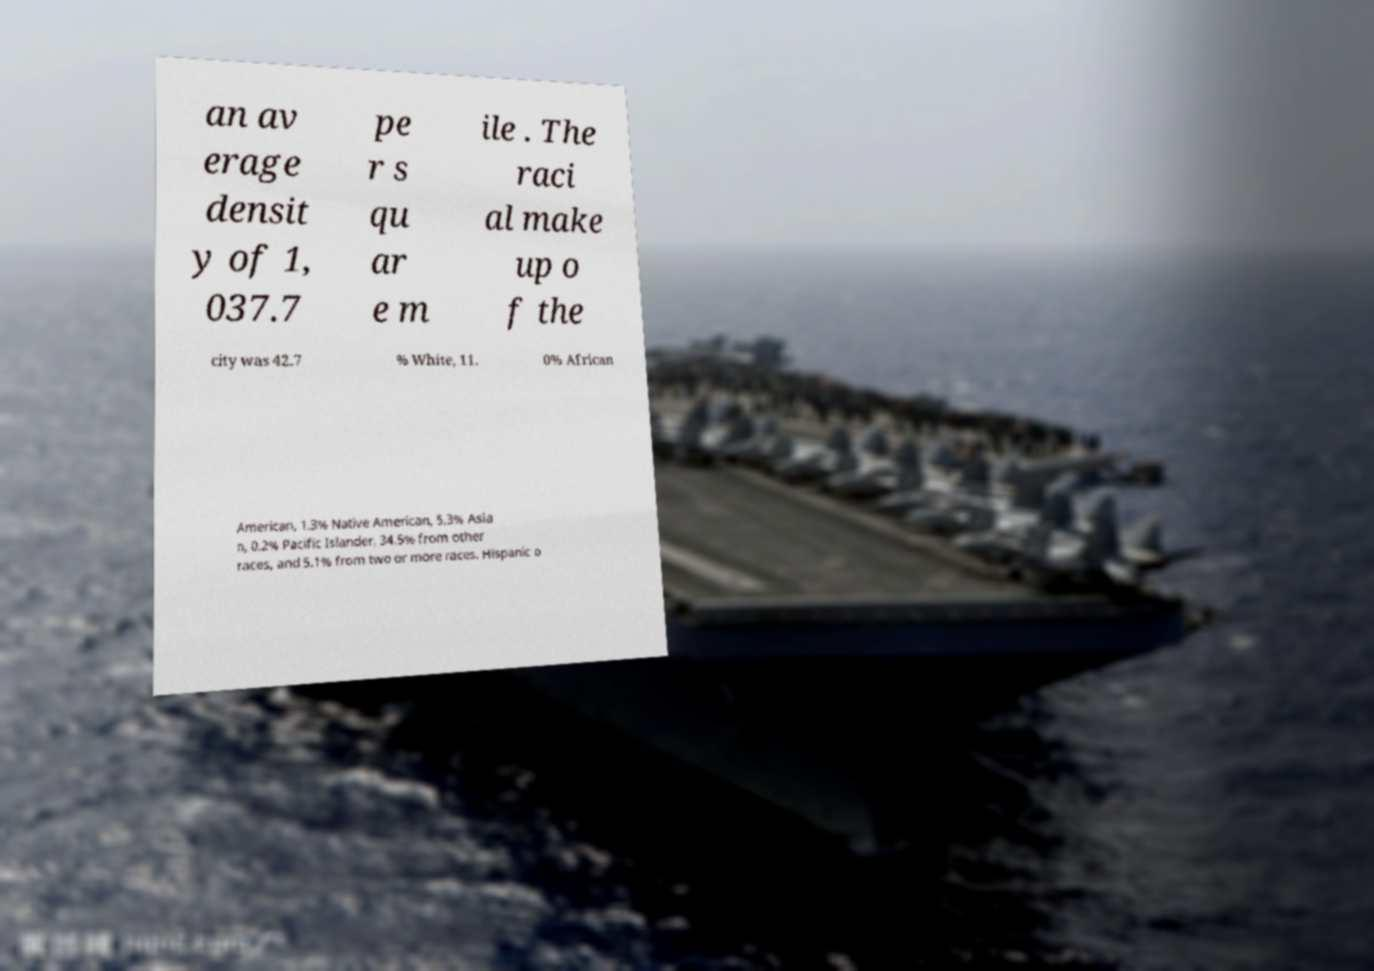Can you accurately transcribe the text from the provided image for me? an av erage densit y of 1, 037.7 pe r s qu ar e m ile . The raci al make up o f the city was 42.7 % White, 11. 0% African American, 1.3% Native American, 5.3% Asia n, 0.2% Pacific Islander, 34.5% from other races, and 5.1% from two or more races. Hispanic o 